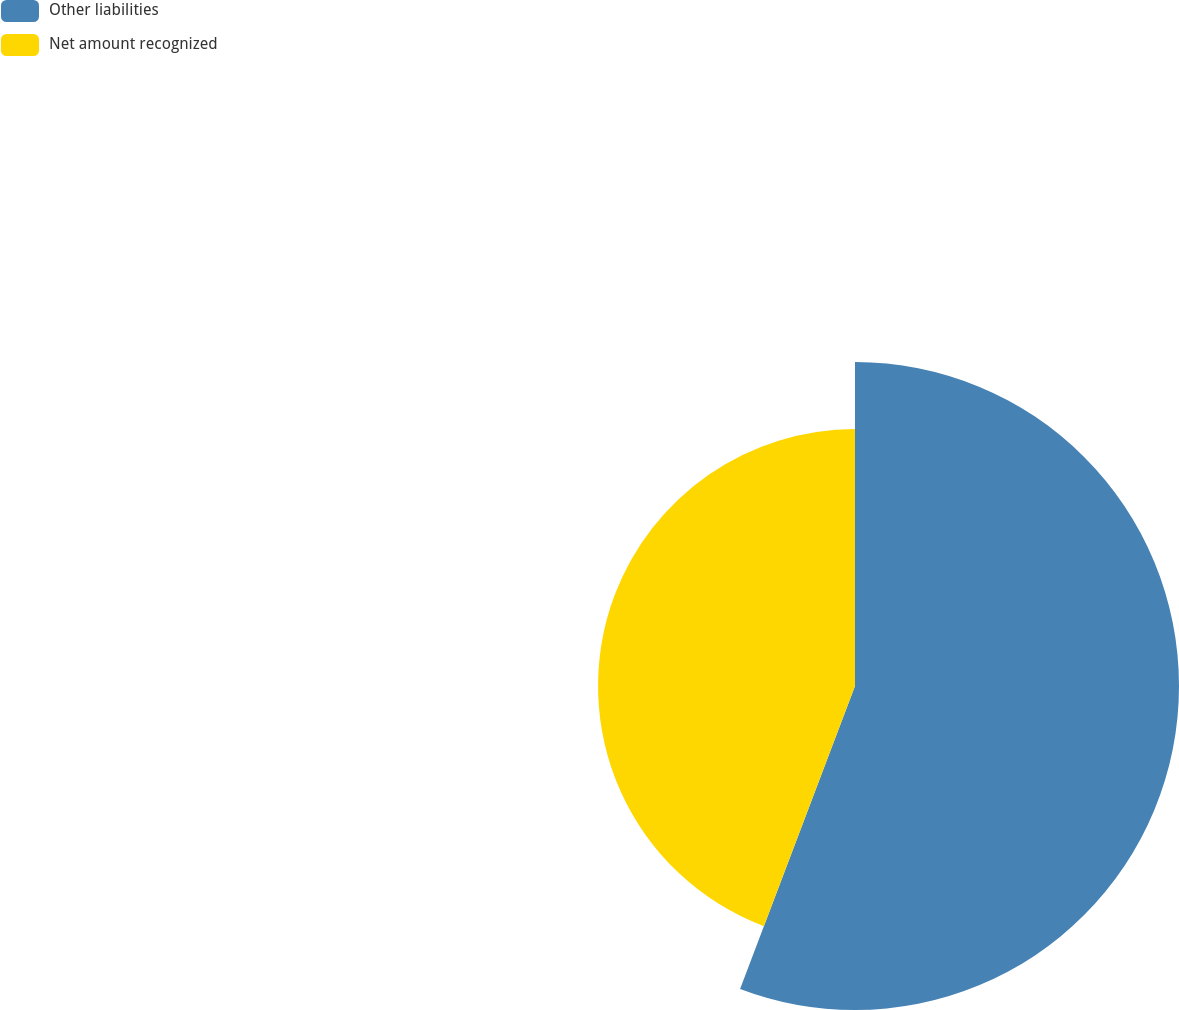Convert chart. <chart><loc_0><loc_0><loc_500><loc_500><pie_chart><fcel>Other liabilities<fcel>Net amount recognized<nl><fcel>55.77%<fcel>44.23%<nl></chart> 